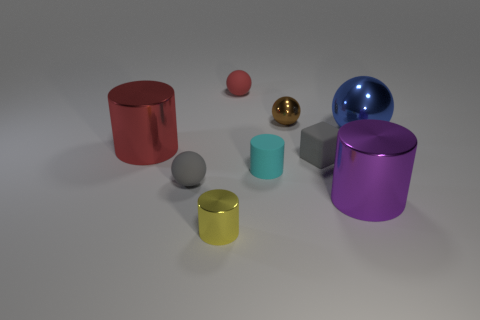Are there fewer red rubber objects than brown metal cylinders?
Provide a succinct answer. No. What is the color of the big shiny thing that is right of the large metal cylinder to the right of the brown ball?
Your answer should be very brief. Blue. What material is the other tiny object that is the same shape as the small yellow metallic object?
Provide a succinct answer. Rubber. What number of metallic things are big purple objects or brown objects?
Provide a short and direct response. 2. Does the gray object left of the brown thing have the same material as the small gray thing that is right of the red ball?
Provide a short and direct response. Yes. Are there any small metallic cubes?
Provide a short and direct response. No. There is a large thing to the right of the large purple thing; is it the same shape as the tiny gray thing to the left of the small red matte ball?
Offer a terse response. Yes. Are there any tiny brown things made of the same material as the big red cylinder?
Make the answer very short. Yes. Is the material of the small cube that is on the right side of the large red metal cylinder the same as the small yellow cylinder?
Offer a very short reply. No. Are there more big blue metallic objects in front of the tiny cyan rubber thing than small yellow shiny things that are on the left side of the small gray sphere?
Make the answer very short. No. 